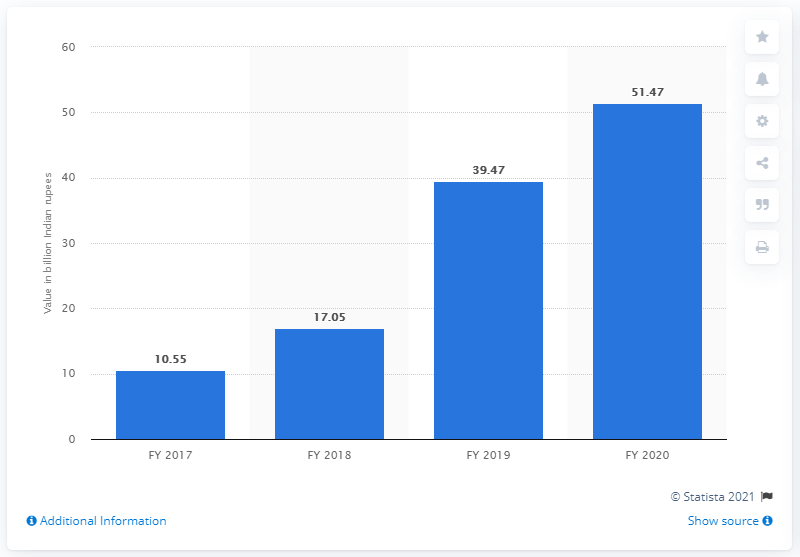Indicate a few pertinent items in this graphic. In the fiscal year 2020, the value of gross non-performing assets at IndusInd Bank Limited was 51.47 Indian Rupees. 